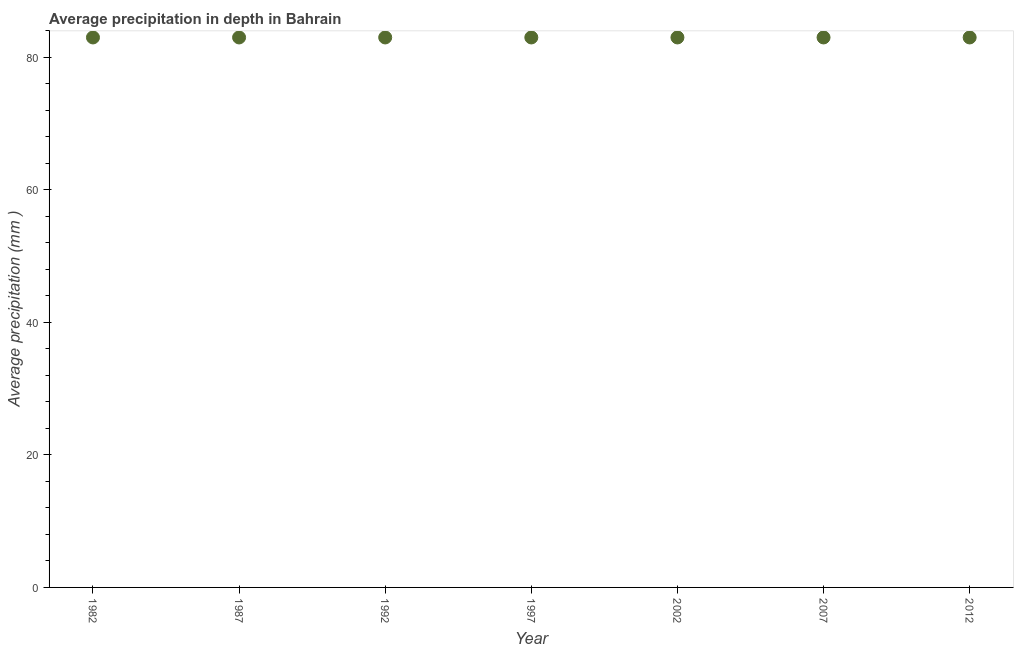What is the average precipitation in depth in 2012?
Provide a short and direct response. 83. Across all years, what is the maximum average precipitation in depth?
Your answer should be compact. 83. Across all years, what is the minimum average precipitation in depth?
Make the answer very short. 83. What is the sum of the average precipitation in depth?
Make the answer very short. 581. What is the median average precipitation in depth?
Ensure brevity in your answer.  83. In how many years, is the average precipitation in depth greater than 44 mm?
Offer a very short reply. 7. What is the ratio of the average precipitation in depth in 2002 to that in 2007?
Offer a very short reply. 1. In how many years, is the average precipitation in depth greater than the average average precipitation in depth taken over all years?
Your answer should be compact. 0. How many dotlines are there?
Your answer should be very brief. 1. What is the difference between two consecutive major ticks on the Y-axis?
Your response must be concise. 20. Does the graph contain any zero values?
Your answer should be very brief. No. Does the graph contain grids?
Ensure brevity in your answer.  No. What is the title of the graph?
Offer a terse response. Average precipitation in depth in Bahrain. What is the label or title of the Y-axis?
Offer a very short reply. Average precipitation (mm ). What is the Average precipitation (mm ) in 1987?
Make the answer very short. 83. What is the Average precipitation (mm ) in 1992?
Offer a terse response. 83. What is the Average precipitation (mm ) in 2002?
Provide a short and direct response. 83. What is the Average precipitation (mm ) in 2012?
Your response must be concise. 83. What is the difference between the Average precipitation (mm ) in 1982 and 1987?
Make the answer very short. 0. What is the difference between the Average precipitation (mm ) in 1982 and 1992?
Provide a succinct answer. 0. What is the difference between the Average precipitation (mm ) in 1982 and 1997?
Ensure brevity in your answer.  0. What is the difference between the Average precipitation (mm ) in 1982 and 2002?
Your response must be concise. 0. What is the difference between the Average precipitation (mm ) in 1982 and 2007?
Ensure brevity in your answer.  0. What is the difference between the Average precipitation (mm ) in 1987 and 1992?
Give a very brief answer. 0. What is the difference between the Average precipitation (mm ) in 1987 and 2002?
Ensure brevity in your answer.  0. What is the difference between the Average precipitation (mm ) in 1987 and 2007?
Your response must be concise. 0. What is the difference between the Average precipitation (mm ) in 1992 and 2002?
Your answer should be compact. 0. What is the difference between the Average precipitation (mm ) in 1992 and 2012?
Offer a very short reply. 0. What is the difference between the Average precipitation (mm ) in 1997 and 2002?
Your answer should be compact. 0. What is the difference between the Average precipitation (mm ) in 1997 and 2007?
Your response must be concise. 0. What is the difference between the Average precipitation (mm ) in 1997 and 2012?
Keep it short and to the point. 0. What is the difference between the Average precipitation (mm ) in 2007 and 2012?
Offer a very short reply. 0. What is the ratio of the Average precipitation (mm ) in 1982 to that in 1987?
Provide a short and direct response. 1. What is the ratio of the Average precipitation (mm ) in 1982 to that in 1997?
Offer a very short reply. 1. What is the ratio of the Average precipitation (mm ) in 1982 to that in 2002?
Your answer should be very brief. 1. What is the ratio of the Average precipitation (mm ) in 1982 to that in 2012?
Offer a terse response. 1. What is the ratio of the Average precipitation (mm ) in 1987 to that in 1992?
Make the answer very short. 1. What is the ratio of the Average precipitation (mm ) in 1987 to that in 2007?
Give a very brief answer. 1. What is the ratio of the Average precipitation (mm ) in 1992 to that in 1997?
Keep it short and to the point. 1. What is the ratio of the Average precipitation (mm ) in 1997 to that in 2002?
Keep it short and to the point. 1. What is the ratio of the Average precipitation (mm ) in 1997 to that in 2007?
Give a very brief answer. 1. What is the ratio of the Average precipitation (mm ) in 1997 to that in 2012?
Keep it short and to the point. 1. What is the ratio of the Average precipitation (mm ) in 2002 to that in 2012?
Keep it short and to the point. 1. 